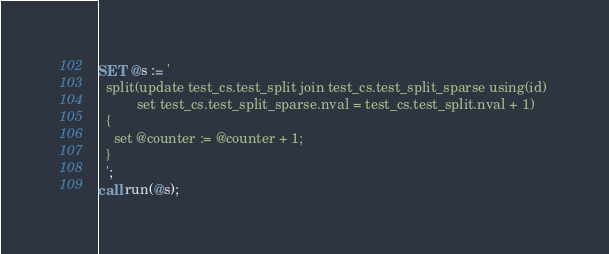<code> <loc_0><loc_0><loc_500><loc_500><_SQL_>SET @s := '
  split(update test_cs.test_split join test_cs.test_split_sparse using(id) 
          set test_cs.test_split_sparse.nval = test_cs.test_split.nval + 1)
  {
    set @counter := @counter + 1;
  }
  ';
call run(@s);

</code> 